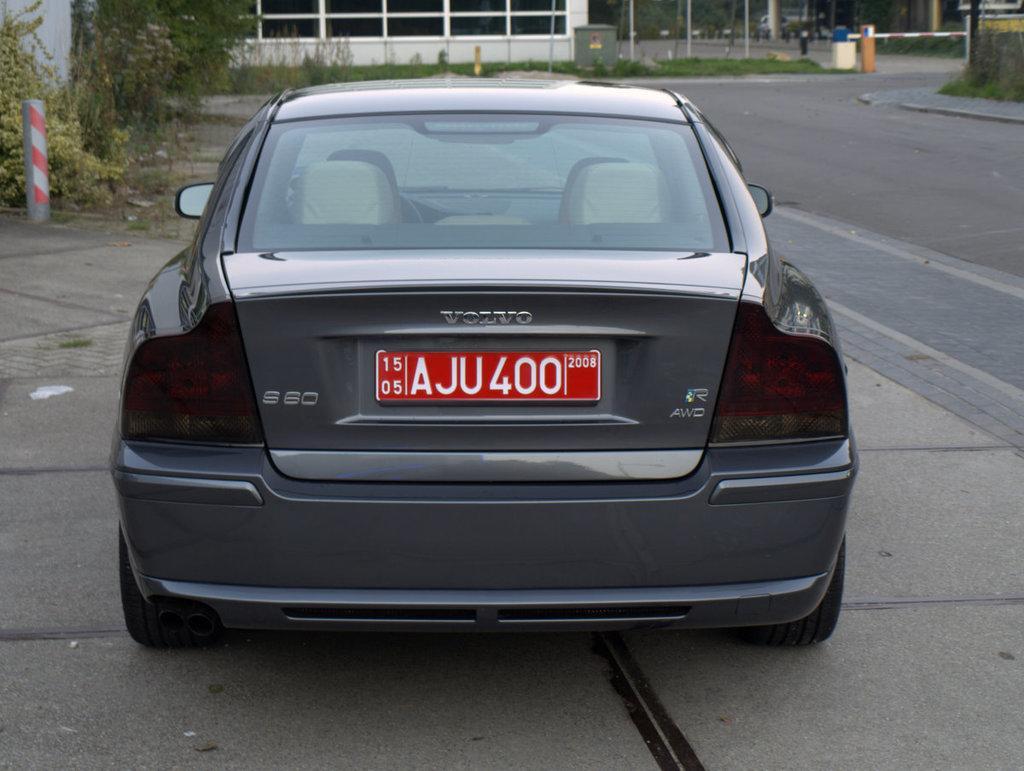In one or two sentences, can you explain what this image depicts? This image is taken outdoors. At the bottom of the image there is a road. In the background there is a ground with grass on it. There are a few plants. There is a building. In the middle of the image a car is parked on the road. 